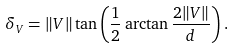<formula> <loc_0><loc_0><loc_500><loc_500>\delta _ { V } = \| V \| \tan \left ( \frac { 1 } { 2 } \arctan \frac { 2 \| V \| } { d } \right ) .</formula> 